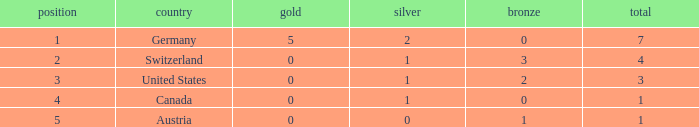What is the total number of bronze when the total is less than 1? None. 